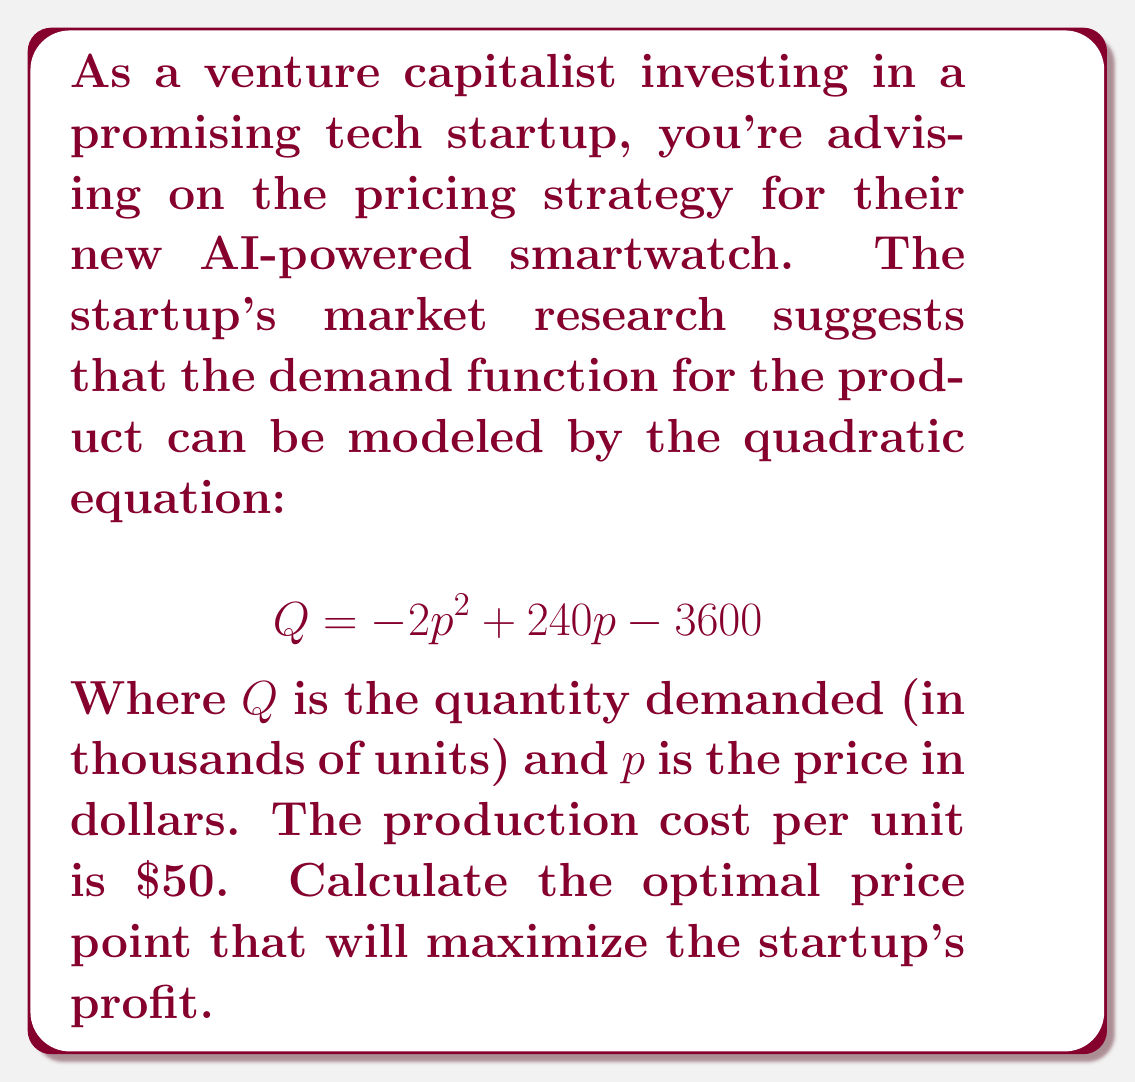Teach me how to tackle this problem. To solve this problem, we'll follow these steps:

1) First, we need to formulate the profit function. Profit is equal to revenue minus cost:
   $$ \text{Profit} = \text{Revenue} - \text{Cost} $$

2) Revenue is price times quantity: $pQ$
   Cost is the number of units times the cost per unit: $50Q$

3) Substituting these into our profit function:
   $$ \text{Profit} = pQ - 50Q = Q(p-50) $$

4) Now, substitute the demand function for $Q$:
   $$ \text{Profit} = (-2p^2 + 240p - 3600)(p-50) $$

5) Expand this:
   $$ \text{Profit} = -2p^3 + 240p^2 - 3600p + 100p^2 - 12000p + 180000 $$
   $$ = -2p^3 + 340p^2 - 15600p + 180000 $$

6) To find the maximum profit, we need to find where the derivative of this function equals zero:
   $$ \frac{d(\text{Profit})}{dp} = -6p^2 + 680p - 15600 = 0 $$

7) This is a quadratic equation. We can solve it using the quadratic formula:
   $$ p = \frac{-b \pm \sqrt{b^2 - 4ac}}{2a} $$
   Where $a=-6$, $b=680$, and $c=-15600$

8) Solving this:
   $$ p = \frac{-680 \pm \sqrt{680^2 - 4(-6)(-15600)}}{2(-6)} $$
   $$ = \frac{-680 \pm \sqrt{462400 - 374400}}{-12} $$
   $$ = \frac{-680 \pm \sqrt{88000}}{-12} $$
   $$ = \frac{-680 \pm 296.6}{-12} $$

9) This gives us two solutions:
   $$ p = 81.4 \text{ or } p = 31.9 $$

10) The second solution can be discarded as it's below our cost of $\$50$ per unit.

Therefore, the optimal price point is $\$81.40$.
Answer: $\$81.40$ 